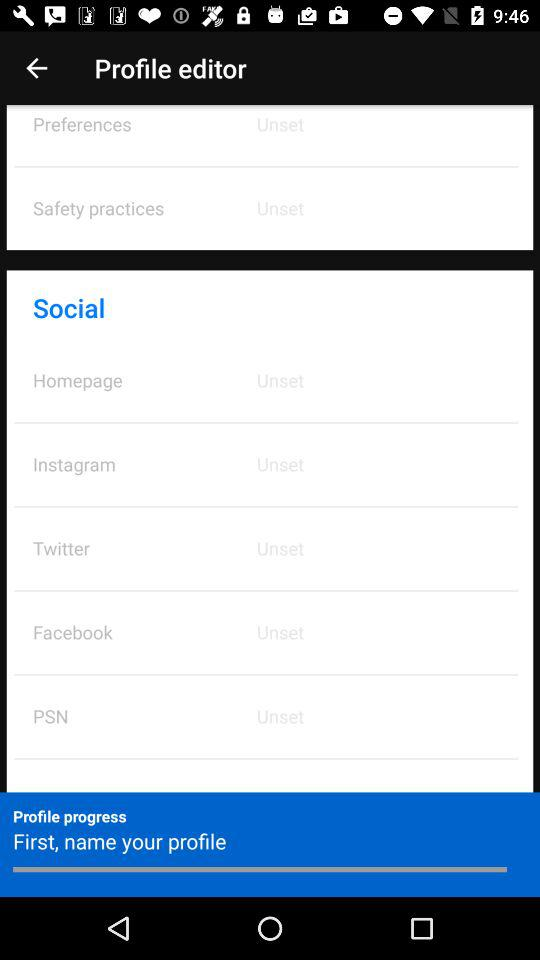How many social media platforms are there?
Answer the question using a single word or phrase. 5 